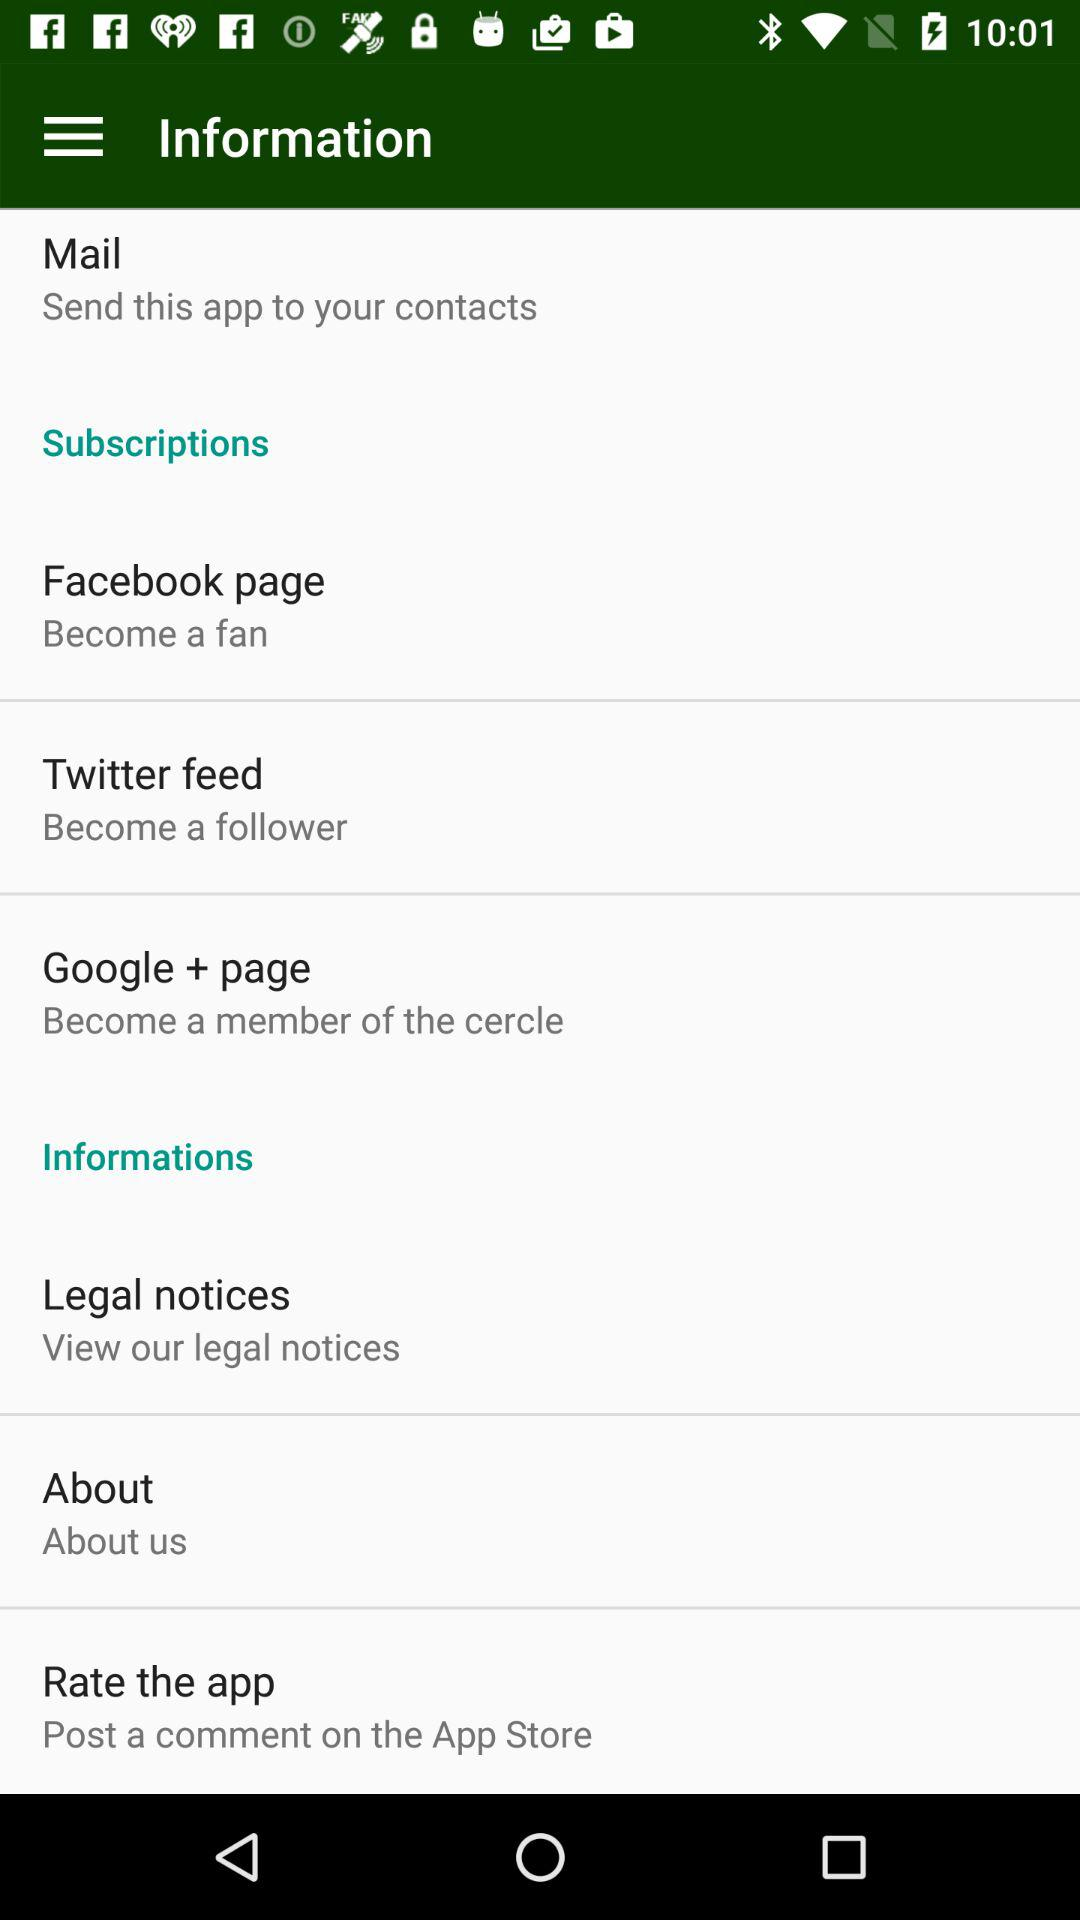How many subscriptions are there?
Answer the question using a single word or phrase. 3 